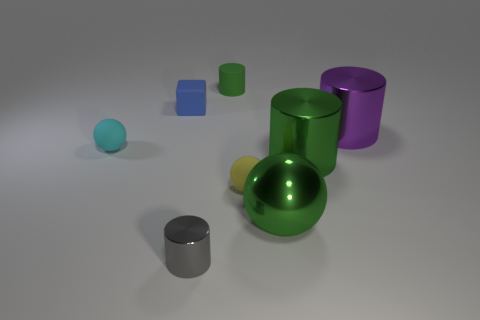Can you describe the lighting setup based on the shadows in the image? The lighting setup appears to be situated above the objects, slightly off to the right, as indicated by the shadows being cast primarily to the left of the objects. The soft edges of the shadows suggest a diffused light source, not very harsh or direct. 